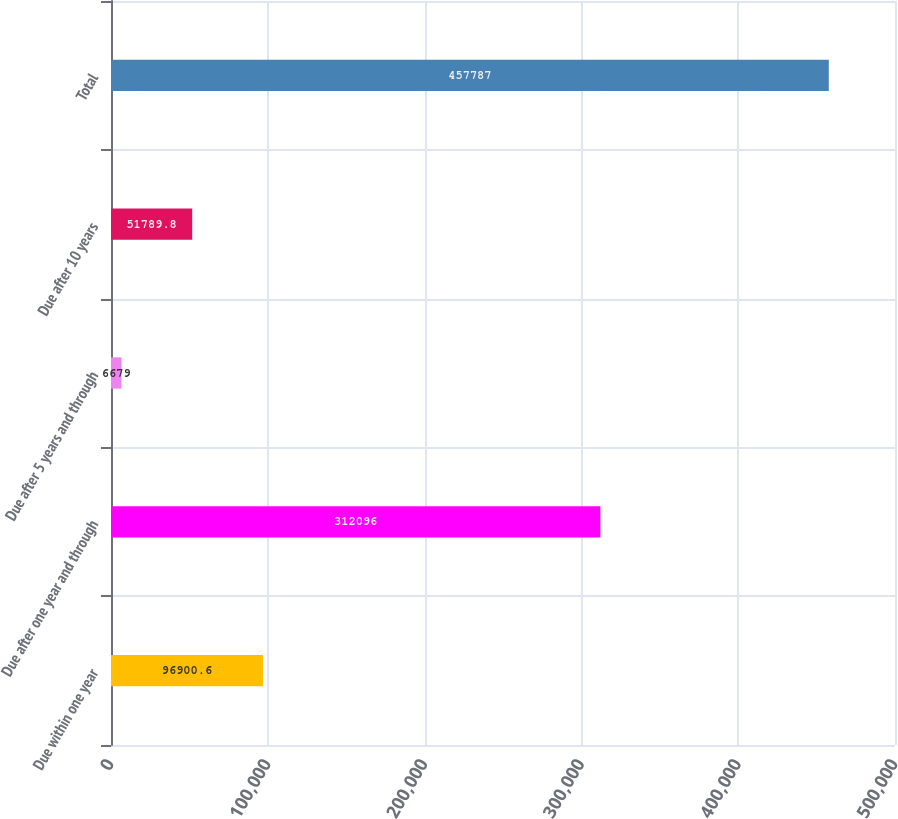<chart> <loc_0><loc_0><loc_500><loc_500><bar_chart><fcel>Due within one year<fcel>Due after one year and through<fcel>Due after 5 years and through<fcel>Due after 10 years<fcel>Total<nl><fcel>96900.6<fcel>312096<fcel>6679<fcel>51789.8<fcel>457787<nl></chart> 